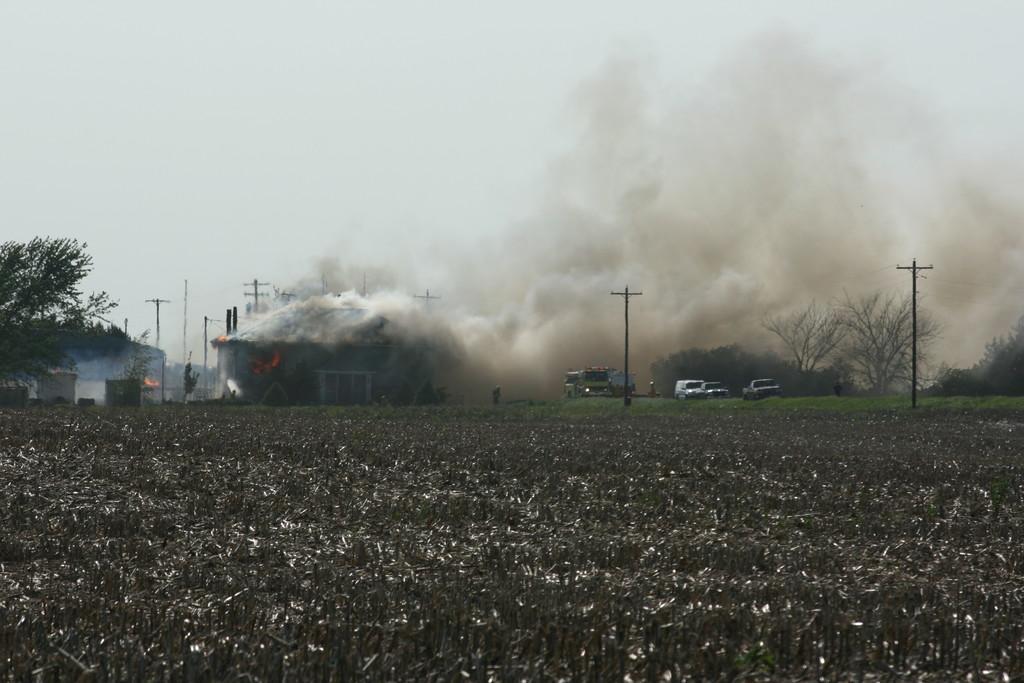Please provide a concise description of this image. In this image there is dry grass on the ground in the center. In the background there are cars, poles, trees, and there is smoke and the sky is cloudy. 